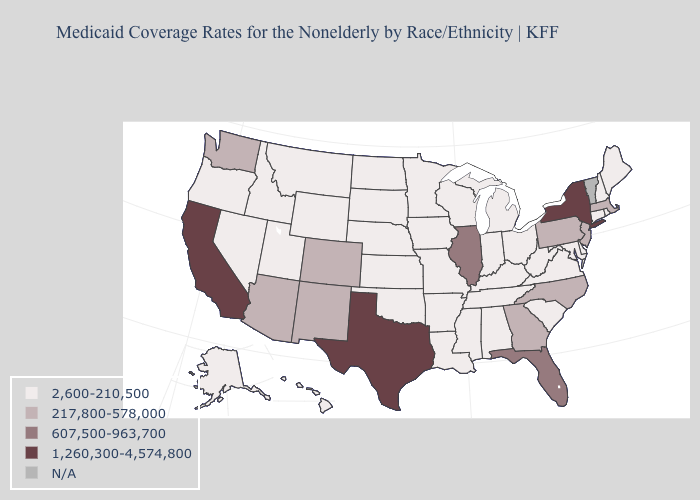What is the value of Colorado?
Write a very short answer. 217,800-578,000. Name the states that have a value in the range 217,800-578,000?
Short answer required. Arizona, Colorado, Georgia, Massachusetts, New Jersey, New Mexico, North Carolina, Pennsylvania, Washington. Name the states that have a value in the range 1,260,300-4,574,800?
Be succinct. California, New York, Texas. How many symbols are there in the legend?
Write a very short answer. 5. What is the value of Delaware?
Be succinct. 2,600-210,500. What is the highest value in states that border Minnesota?
Concise answer only. 2,600-210,500. Name the states that have a value in the range 607,500-963,700?
Concise answer only. Florida, Illinois. Is the legend a continuous bar?
Answer briefly. No. Does Minnesota have the lowest value in the MidWest?
Concise answer only. Yes. Name the states that have a value in the range 607,500-963,700?
Keep it brief. Florida, Illinois. Name the states that have a value in the range 1,260,300-4,574,800?
Quick response, please. California, New York, Texas. Name the states that have a value in the range 217,800-578,000?
Write a very short answer. Arizona, Colorado, Georgia, Massachusetts, New Jersey, New Mexico, North Carolina, Pennsylvania, Washington. Does Texas have the lowest value in the South?
Quick response, please. No. What is the highest value in the South ?
Short answer required. 1,260,300-4,574,800. What is the value of New Hampshire?
Keep it brief. 2,600-210,500. 